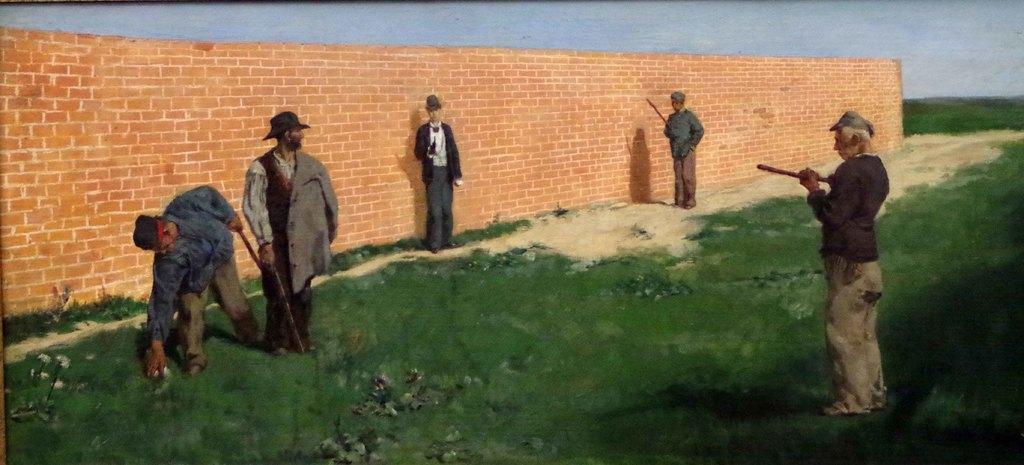Describe this image in one or two sentences. In this picture there is a person standing on a greenery ground in the right corner and there are four other persons standing in front of him and there is a wall in the left corner. 